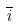<formula> <loc_0><loc_0><loc_500><loc_500>\overline { i }</formula> 